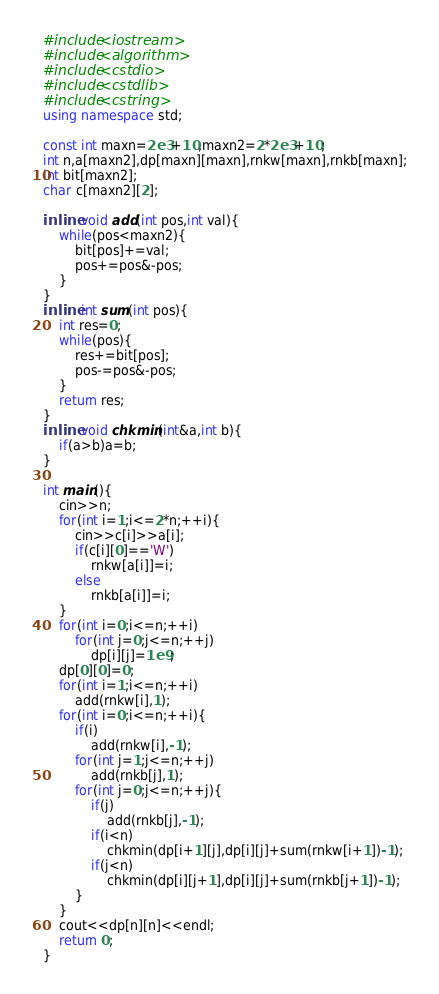<code> <loc_0><loc_0><loc_500><loc_500><_C++_>#include<iostream>
#include<algorithm>
#include<cstdio>
#include<cstdlib>
#include<cstring>
using namespace std;
 
const int maxn=2e3+10,maxn2=2*2e3+10;
int n,a[maxn2],dp[maxn][maxn],rnkw[maxn],rnkb[maxn];
int bit[maxn2];
char c[maxn2][2];
 
inline void add(int pos,int val){
	while(pos<maxn2){
		bit[pos]+=val;
		pos+=pos&-pos;
	}
}
inline int sum(int pos){
	int res=0;
	while(pos){
		res+=bit[pos];
		pos-=pos&-pos;
	}
	return res;
}
inline void chkmin(int&a,int b){
	if(a>b)a=b;
}
 
int main(){
	cin>>n;
	for(int i=1;i<=2*n;++i){
		cin>>c[i]>>a[i];
		if(c[i][0]=='W')
			rnkw[a[i]]=i;
		else
			rnkb[a[i]]=i;
	}
	for(int i=0;i<=n;++i)
		for(int j=0;j<=n;++j)
			dp[i][j]=1e9;
	dp[0][0]=0;
	for(int i=1;i<=n;++i)
		add(rnkw[i],1);
	for(int i=0;i<=n;++i){
		if(i)
			add(rnkw[i],-1);
		for(int j=1;j<=n;++j)
			add(rnkb[j],1);
		for(int j=0;j<=n;++j){
			if(j)
				add(rnkb[j],-1);
			if(i<n)
				chkmin(dp[i+1][j],dp[i][j]+sum(rnkw[i+1])-1);
			if(j<n)
				chkmin(dp[i][j+1],dp[i][j]+sum(rnkb[j+1])-1);
		}
	}
	cout<<dp[n][n]<<endl;
	return 0;
}</code> 